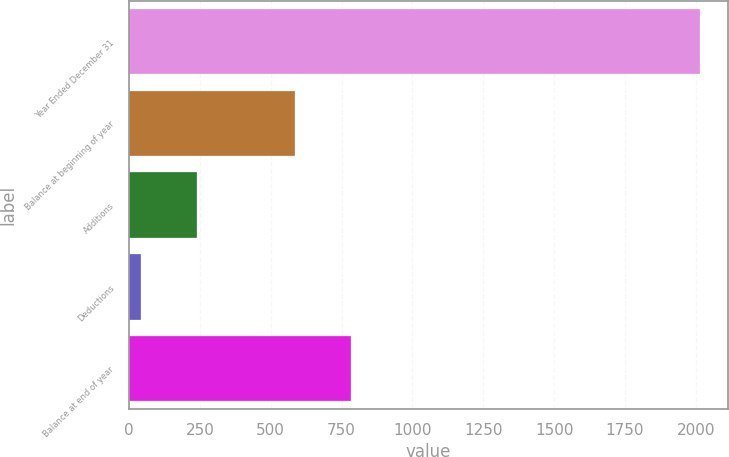Convert chart. <chart><loc_0><loc_0><loc_500><loc_500><bar_chart><fcel>Year Ended December 31<fcel>Balance at beginning of year<fcel>Additions<fcel>Deductions<fcel>Balance at end of year<nl><fcel>2014<fcel>586<fcel>238.3<fcel>41<fcel>783.3<nl></chart> 